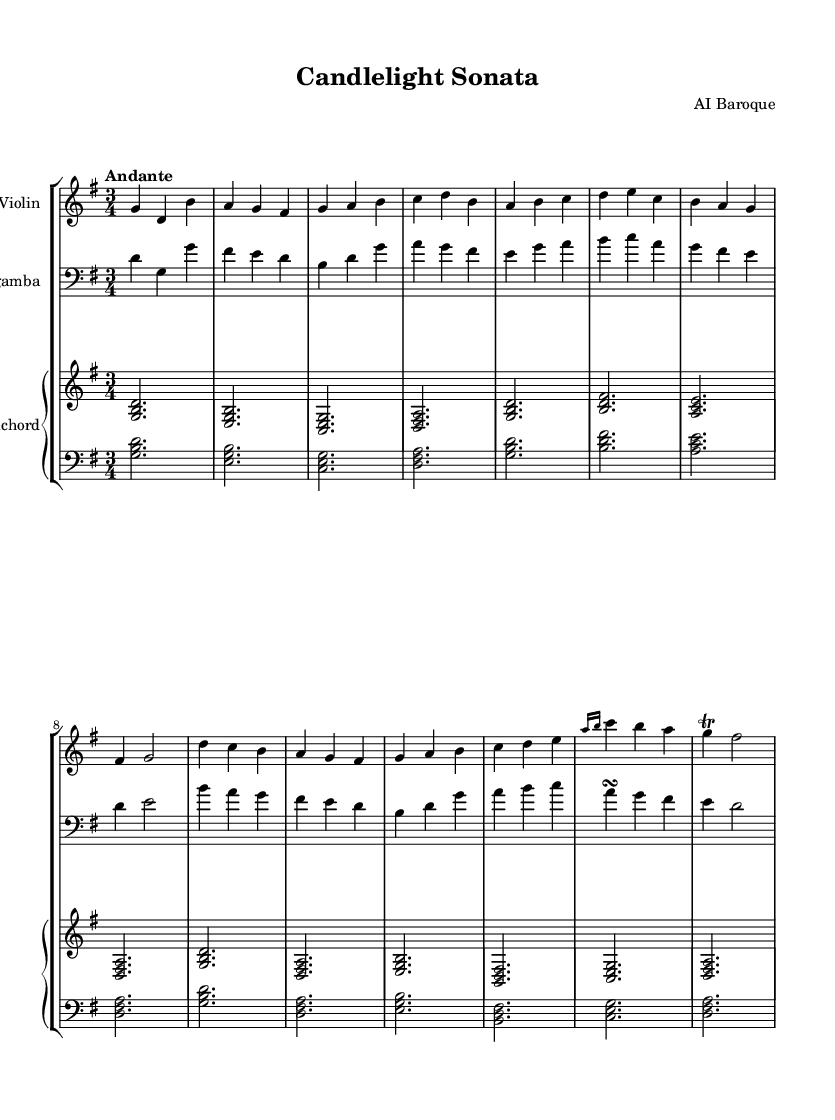What is the key signature of this music? The key signature is G major, which has one sharp (F#).
Answer: G major What is the time signature of the piece? The time signature is 3/4, indicating three beats per measure, with a quarter note receiving one beat.
Answer: 3/4 What is the tempo indication for this music? The tempo marking states "Andante," which typically means a moderately slow tempo.
Answer: Andante How many sections does the piece have, based on the music notation? The piece has two sections: Section A and Section B. This is indicated by the annotations in the sheet music.
Answer: Two sections In which instruments is this piece composed for? The piece is composed for violin, viola da gamba, and harpsichord, as indicated by the staff names under each instrument.
Answer: Violin, viola da gamba, harpsichord What kind of ornaments are used in this sheet music? The sheet music indicates the use of a grace note and a trill (_grace_ and _trill_ notation) as decorative embellishments in the melody.
Answer: Grace note, trill How does the counterpoint in Section B relate to Section A? The counterpoint in Section B complements the primary melodies of Section A by providing harmonic support and counter-melodies, seen through the notation of both sections.
Answer: Complementary 